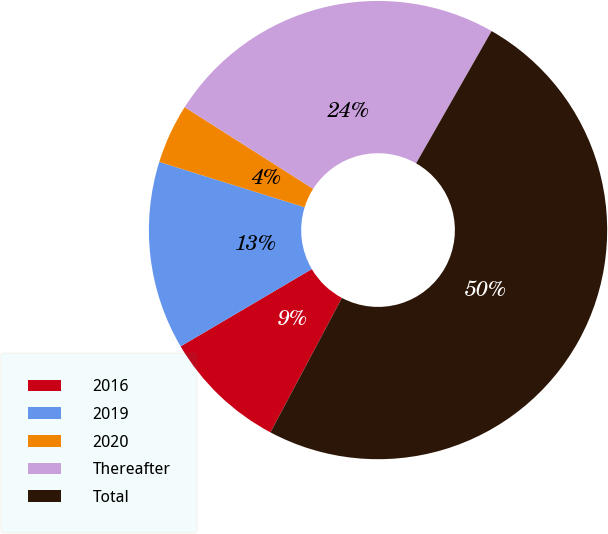<chart> <loc_0><loc_0><loc_500><loc_500><pie_chart><fcel>2016<fcel>2019<fcel>2020<fcel>Thereafter<fcel>Total<nl><fcel>8.75%<fcel>13.28%<fcel>4.21%<fcel>24.24%<fcel>49.53%<nl></chart> 